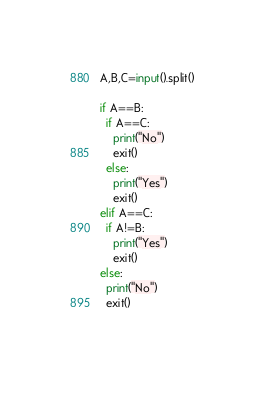<code> <loc_0><loc_0><loc_500><loc_500><_Python_>A,B,C=input().split()

if A==B:
  if A==C:
    print("No")
    exit()
  else:
    print("Yes")
    exit()
elif A==C:
  if A!=B:
    print("Yes")
    exit()
else:
  print("No")
  exit()
    </code> 